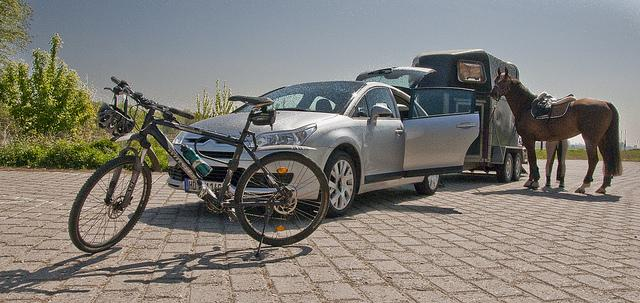What is being used to pull the black trailer?

Choices:
A) dog
B) men
C) bike
D) car car 